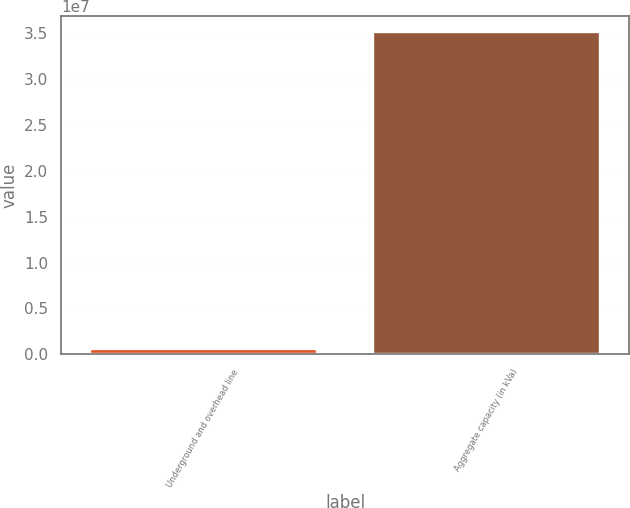<chart> <loc_0><loc_0><loc_500><loc_500><bar_chart><fcel>Underground and overhead line<fcel>Aggregate capacity (in kVa)<nl><fcel>618387<fcel>3.5098e+07<nl></chart> 